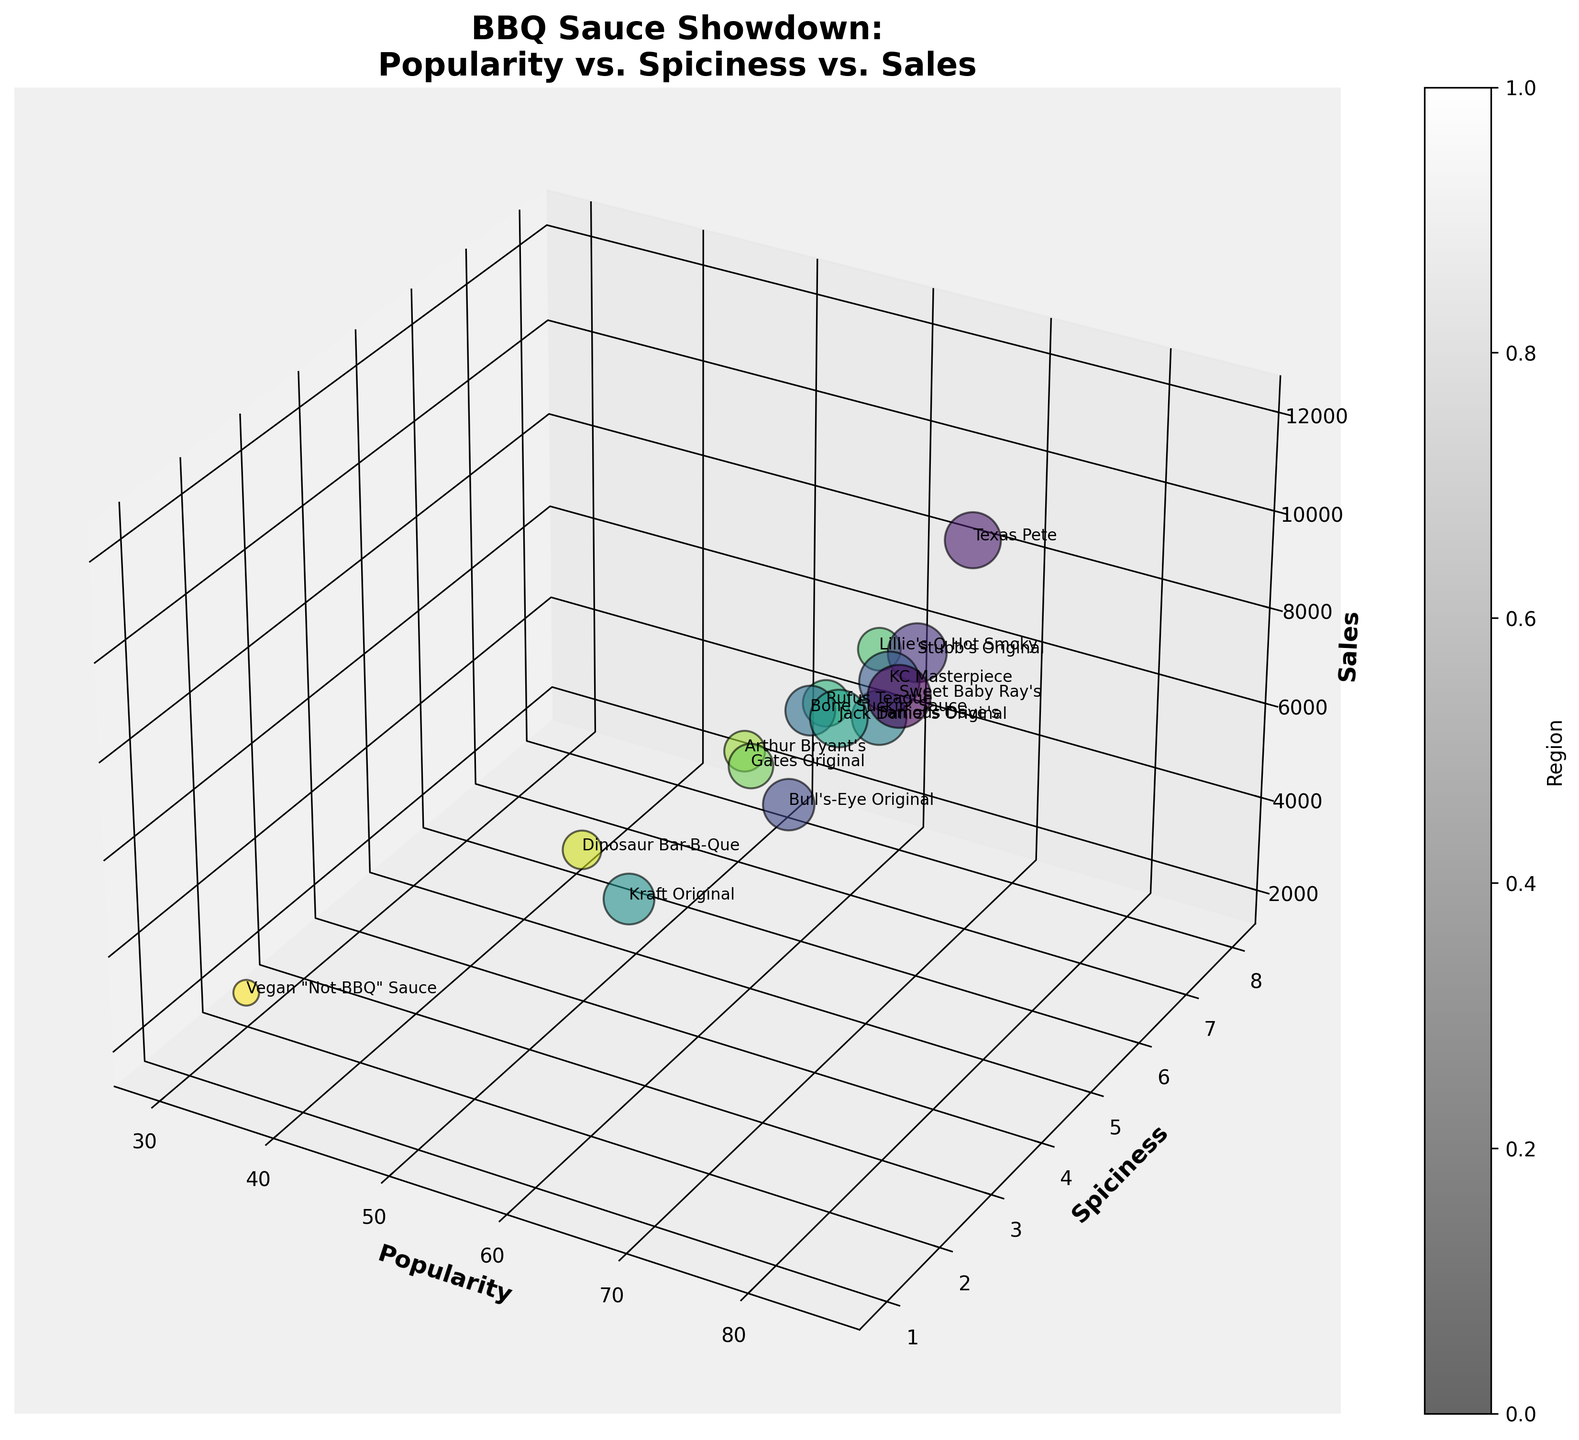how many sauces are represented in the figure? By counting the data points in the figure, you can determine there are 15 sauces represented. Each bubble corresponds to one sauce making it easy to count.
Answer: 15 What is the title of the figure? The title is typically displayed at the top of the chart. The title in this figure is "BBQ Sauce Showdown: Popularity vs. Spiciness vs. Sales".
Answer: BBQ Sauce Showdown: Popularity vs. Spiciness vs. Sales Which sauce has the highest sales? By observing the z-axis and identifying the highest bubble, you find that "Sweet Baby Ray's" has the highest sales.
Answer: Sweet Baby Ray's How does the popularity of "Vegan 'Not-BBQ' Sauce" compare to "Sweet Baby Ray's"? By observing the x-axis (Popularity), you can see that "Sweet Baby Ray's" (85) is significantly more popular than "Vegan 'Not-BBQ' Sauce" (30).
Answer: Lower Which sauce has the highest spiciness and how are its sales? Identify the bubble positioned at the highest point on the y-axis (Spiciness = 8). "Lillie's Q Hot Smoky" has the highest spiciness, with sales at 5500.
Answer: Lillie's Q Hot Smoky, 5500 What is the average popularity of sauces from the Midwest region? Locate all the bubbles representing Midwest (Sweet Baby Ray's, KC Masterpiece, Rufus Teague, Gates Original, Arthur Bryant's). Their popularities are 85, 80, 62, 60, and 55 respectively. The average is (85+80+62+60+55)/5 = 68.4
Answer: 68.4 Which region has the sauce with the highest spiciness? Identify the sauce with the highest spiciness (Lillie's Q Hot Smoky), then look at its region which is displayed as Southeast.
Answer: Southeast Which sauce has similar spiciness to "Kraft Original" but higher sales? "Kraft Original" has a spiciness level of 1. Look for sauces with similar spiciness levels and compare their sales. "Sweet Baby Ray's" with spiciness level 2 has higher sales (12000).
Answer: Sweet Baby Ray's How many sauces have a popularity above 70 and spiciness below 5? Count the bubbles where the x-axis value (Popularity) is more than 70 and y-axis value (Spiciness) is less than 5. This includes Sweet Baby Ray's, Stubb's Original, KC Masterpiece, Bull's-Eye Original, and Famous Dave's.
Answer: 5 What is the combined sales of all sauces from the South region? Sum the sales of Texas Pete (9500) and Jack Daniel's Original (10000). Thus, the combined sales are 9500 + 10000 = 19500.
Answer: 19500 